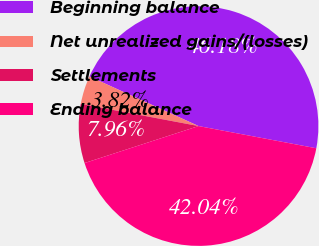Convert chart. <chart><loc_0><loc_0><loc_500><loc_500><pie_chart><fcel>Beginning balance<fcel>Net unrealized gains/(losses)<fcel>Settlements<fcel>Ending balance<nl><fcel>46.18%<fcel>3.82%<fcel>7.96%<fcel>42.04%<nl></chart> 